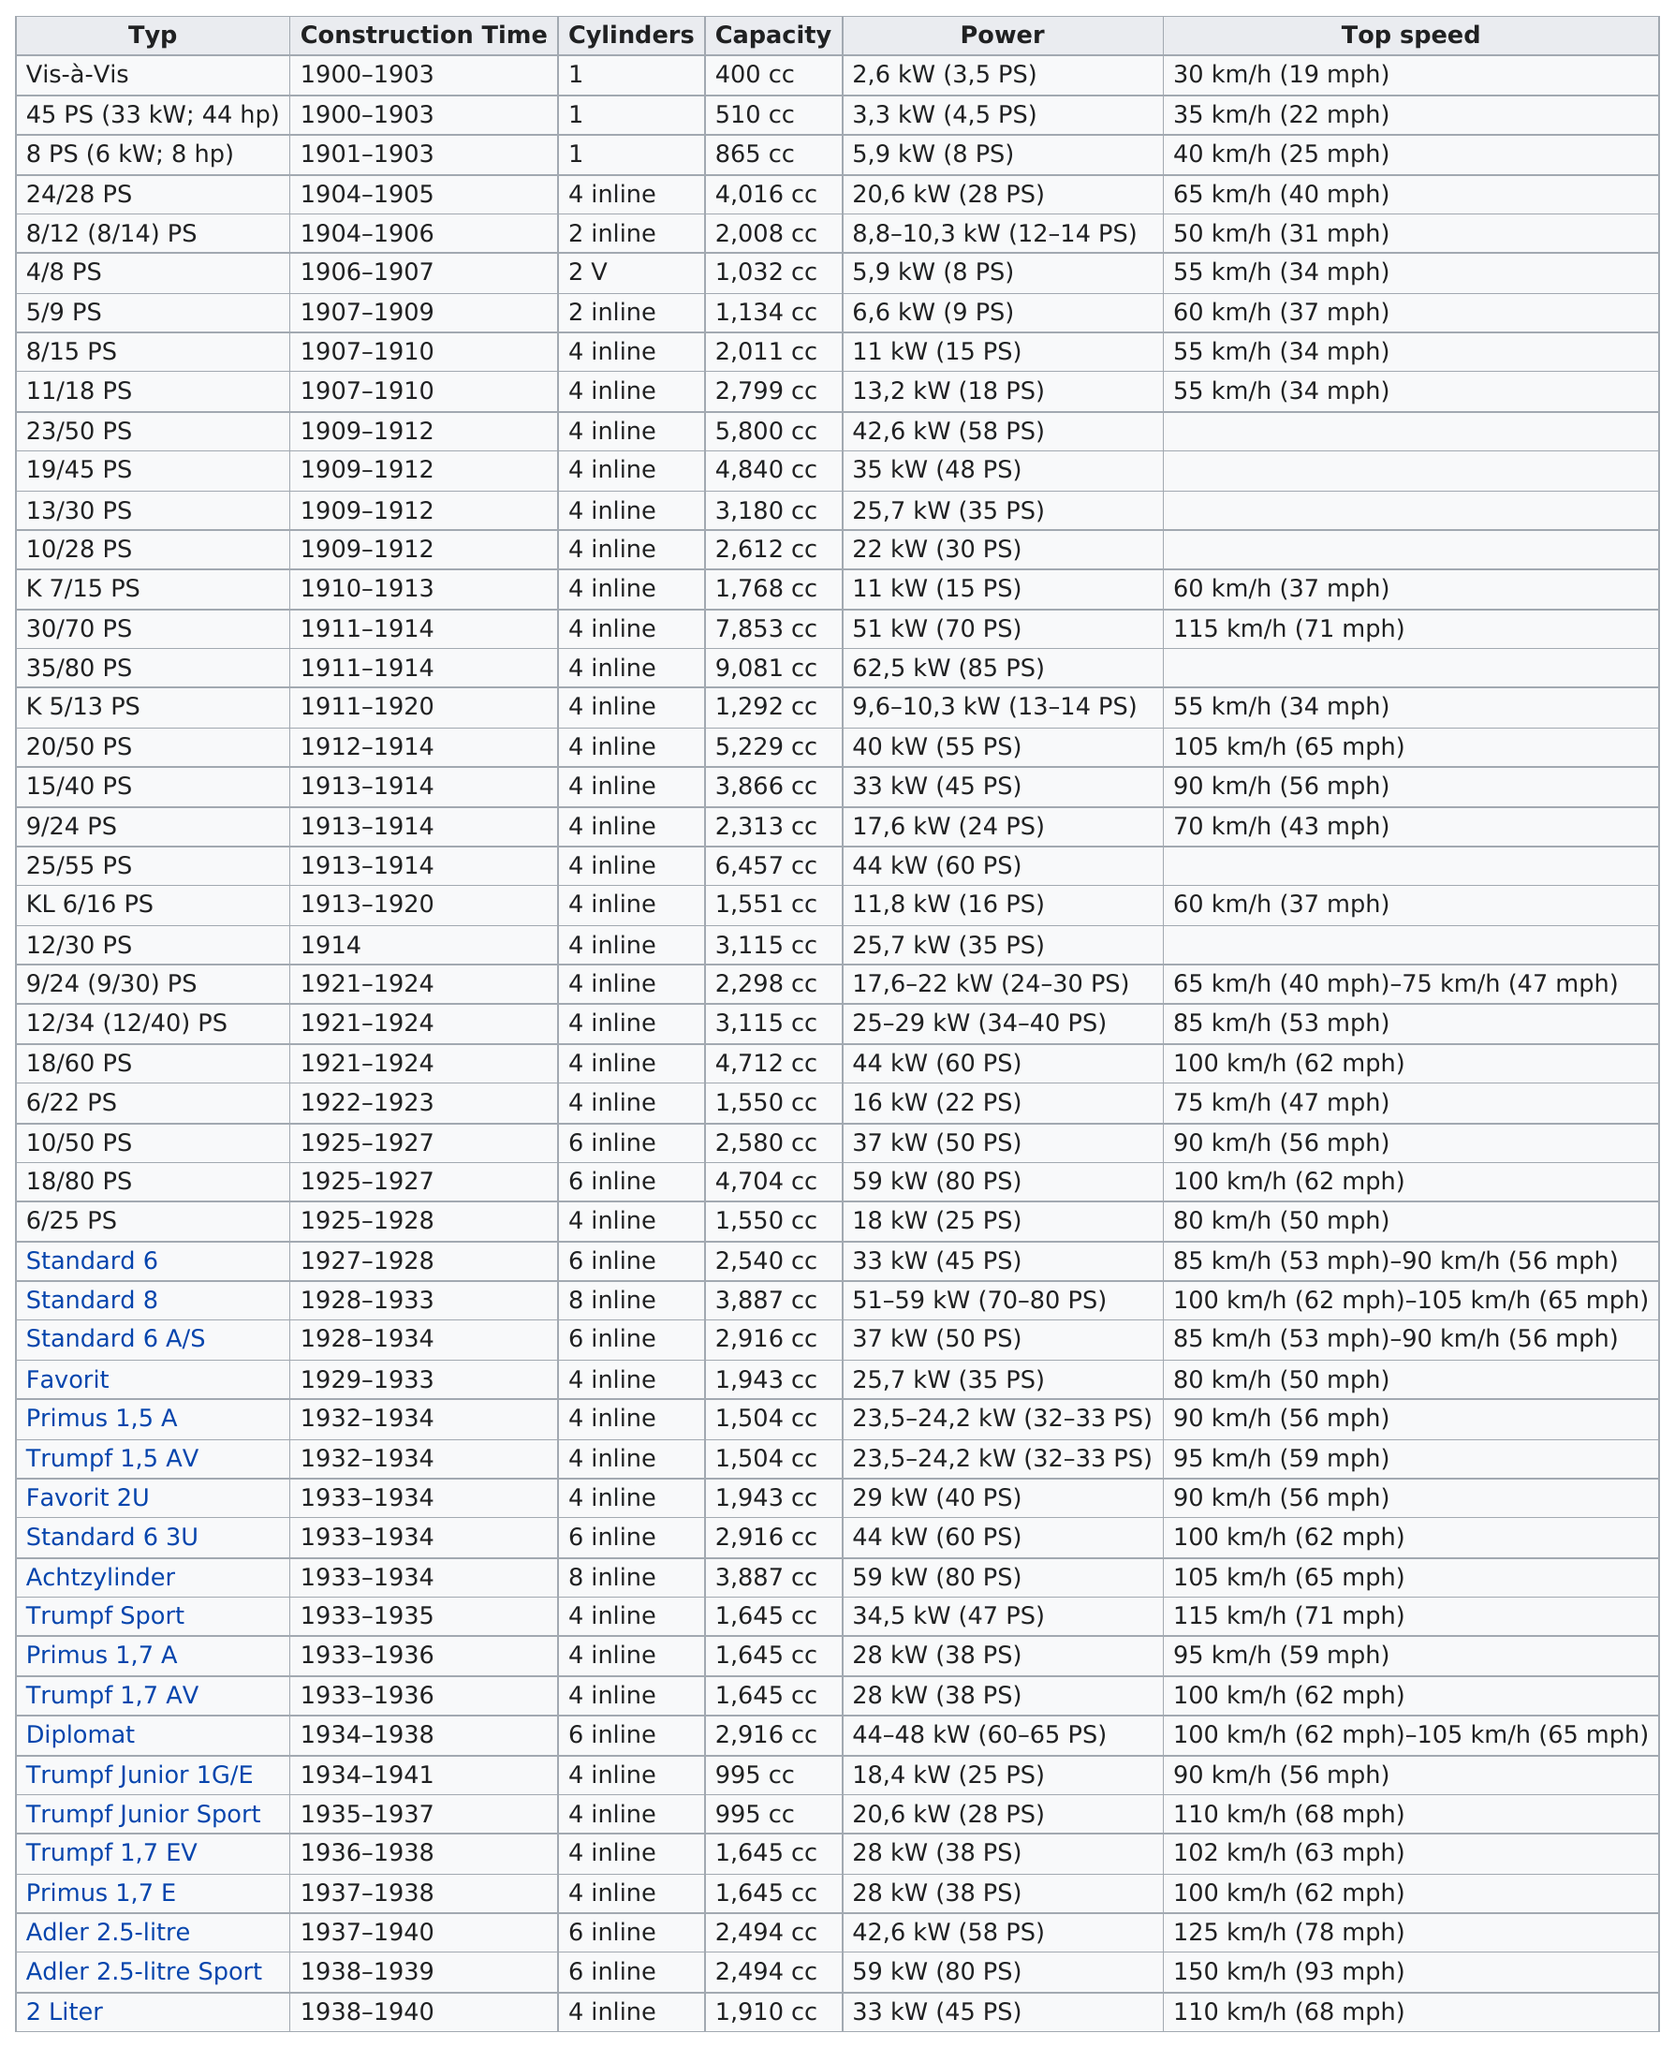Mention a couple of crucial points in this snapshot. There are four types that have a top speed above 30 mph. The 2-liter engine has the longest construction time of all three options. The study found that the typ(s) with the longest construction times were K 5/13. The standard 8 cylinders have 8 inline cylinders. The 4/8 PS was built before the K 5/13 PS. 